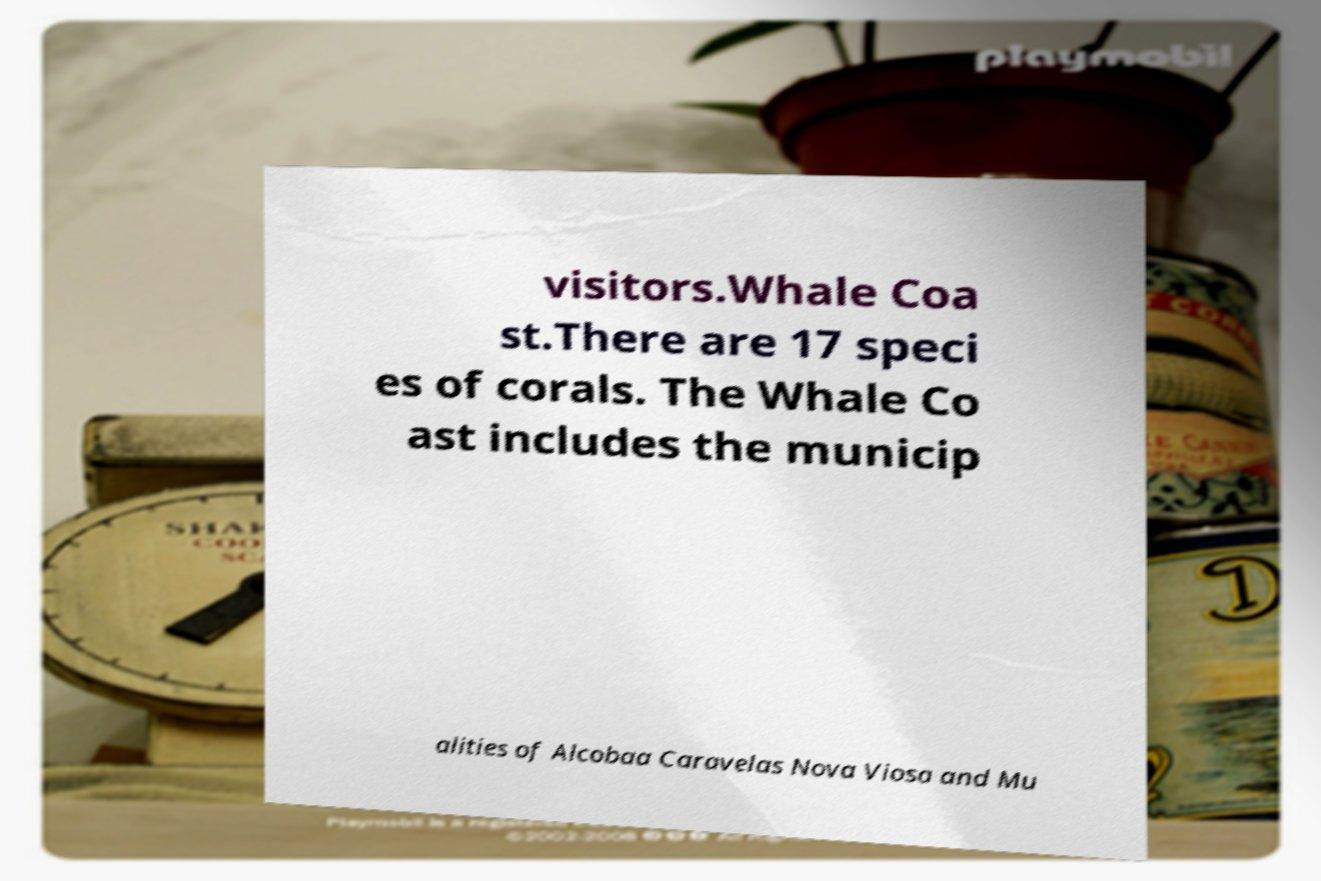Please read and relay the text visible in this image. What does it say? visitors.Whale Coa st.There are 17 speci es of corals. The Whale Co ast includes the municip alities of Alcobaa Caravelas Nova Viosa and Mu 